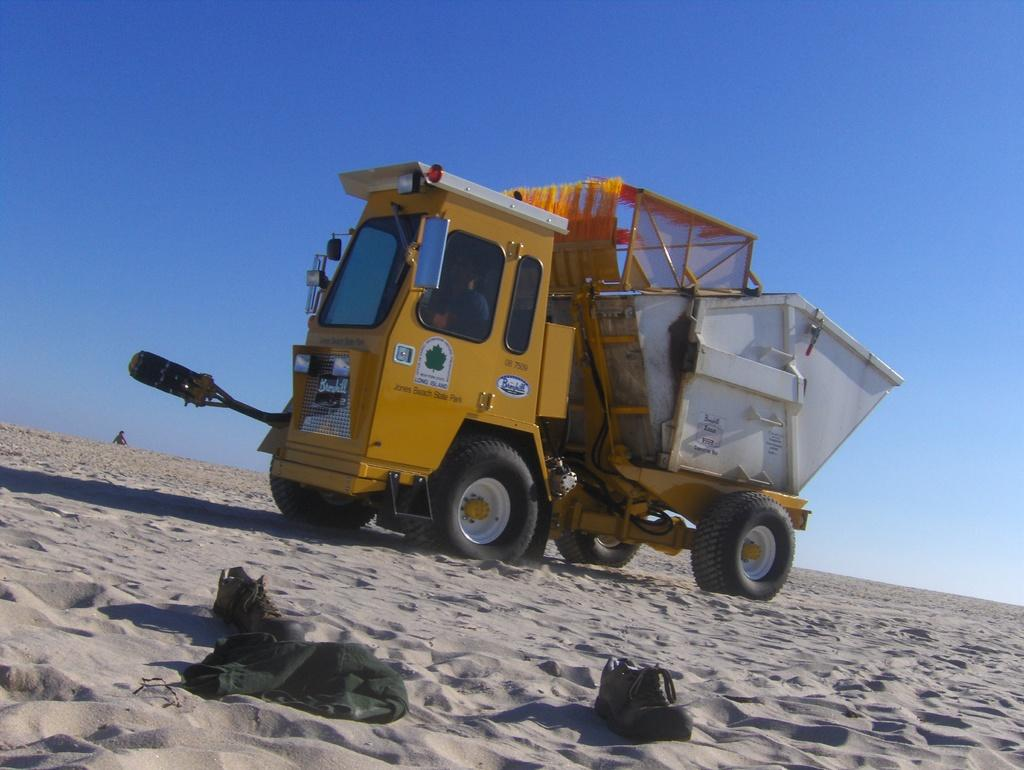What is the main subject of the image? The main subject of the image is a truck. Where is the truck located in the image? The truck is on the sand in the image. What can be seen in the background of the image? The sky is visible in the image. What are some features of the truck? The truck has wheels, headlights, and a mirror. How many rabbits can be seen playing with the shoes on the sand in the image? There are no rabbits present in the image; it only features a truck, sand, sky, and shoes. Why is the truck crying in the image? The truck is not crying in the image; it is a vehicle and does not have emotions. 